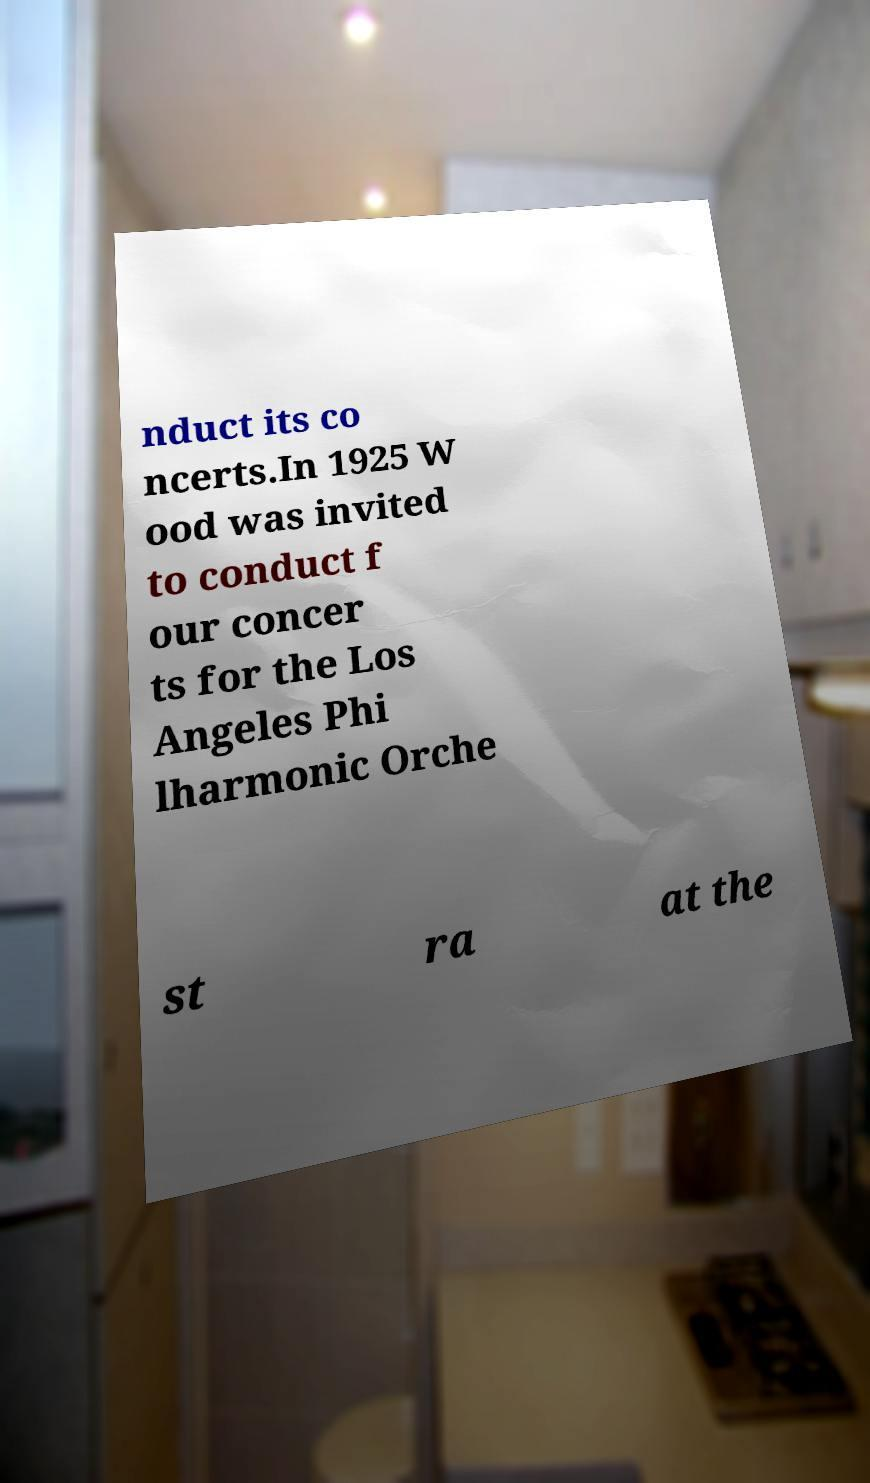Could you extract and type out the text from this image? nduct its co ncerts.In 1925 W ood was invited to conduct f our concer ts for the Los Angeles Phi lharmonic Orche st ra at the 